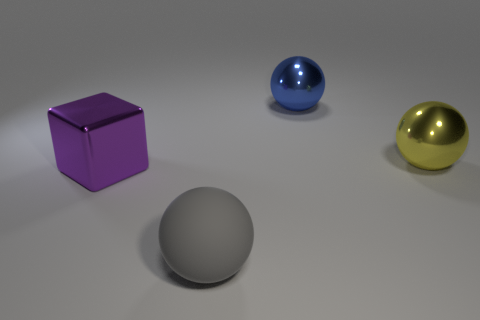Add 4 green shiny cylinders. How many objects exist? 8 Subtract all blocks. How many objects are left? 3 Add 4 gray things. How many gray things are left? 5 Add 4 small red metal cylinders. How many small red metal cylinders exist? 4 Subtract 1 purple cubes. How many objects are left? 3 Subtract all large purple shiny objects. Subtract all big metallic things. How many objects are left? 0 